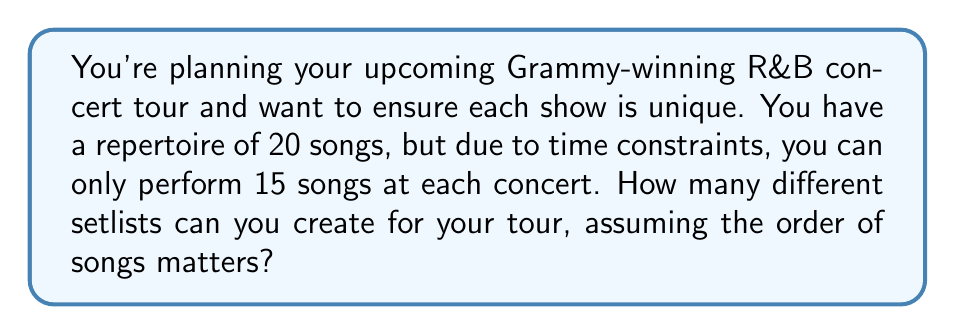Provide a solution to this math problem. Let's approach this step-by-step:

1) This is a permutation problem. We are selecting 15 songs out of 20 and the order matters (as it's a setlist for a concert).

2) The formula for permutations is:

   $$P(n,r) = \frac{n!}{(n-r)!}$$

   Where $n$ is the total number of items to choose from, and $r$ is the number of items being chosen.

3) In this case, $n = 20$ (total songs) and $r = 15$ (songs in each setlist).

4) Plugging these numbers into our formula:

   $$P(20,15) = \frac{20!}{(20-15)!} = \frac{20!}{5!}$$

5) Let's calculate this:
   
   $$\frac{20!}{5!} = \frac{20 \times 19 \times 18 \times 17 \times 16 \times 15!}{5!}$$

6) The 15! cancels out in the numerator and denominator:

   $$20 \times 19 \times 18 \times 17 \times 16 = 1,860,480$$

Therefore, you can create 1,860,480 different setlists for your Grammy-winning R&B concert tour.
Answer: 1,860,480 